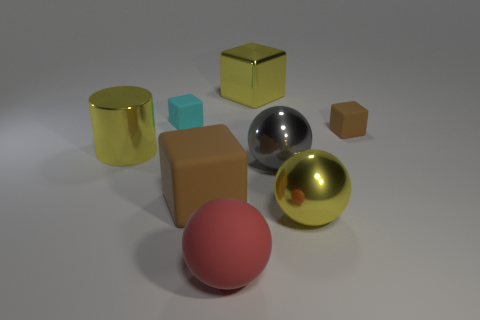Subtract 1 cubes. How many cubes are left? 3 Add 1 tiny cyan things. How many objects exist? 9 Subtract all cylinders. How many objects are left? 7 Add 7 big gray shiny objects. How many big gray shiny objects are left? 8 Add 5 large yellow cubes. How many large yellow cubes exist? 6 Subtract 1 yellow blocks. How many objects are left? 7 Subtract all big gray metal spheres. Subtract all large red rubber objects. How many objects are left? 6 